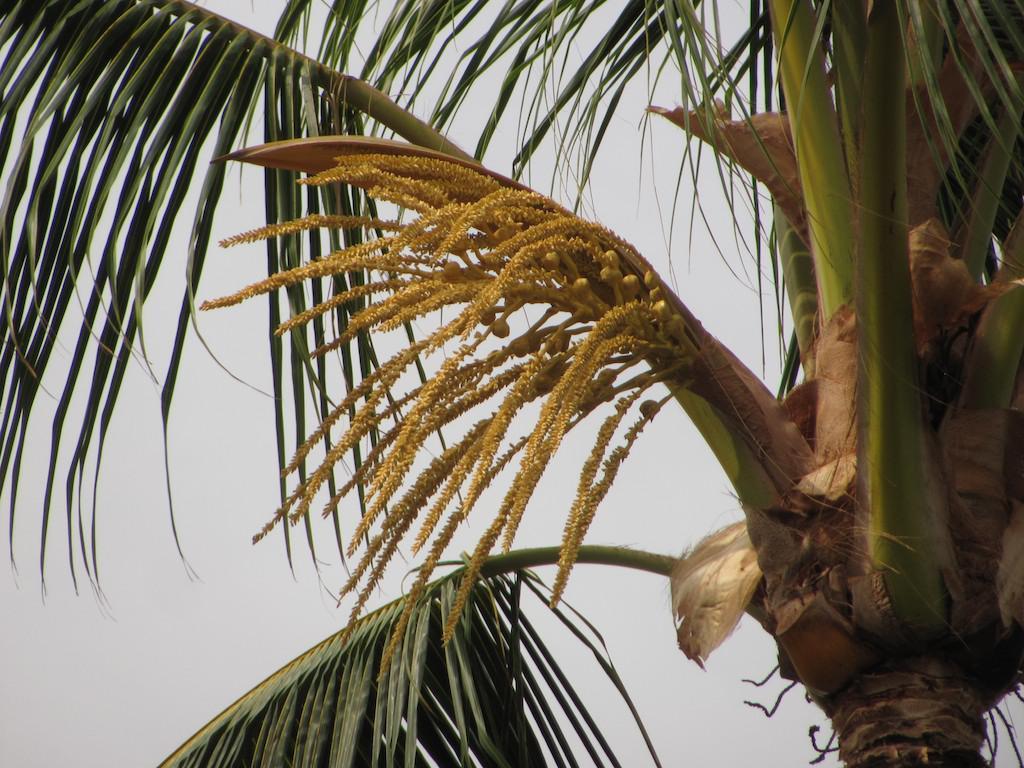Describe this image in one or two sentences. In this image in the front there is a and the sky is cloudy. 